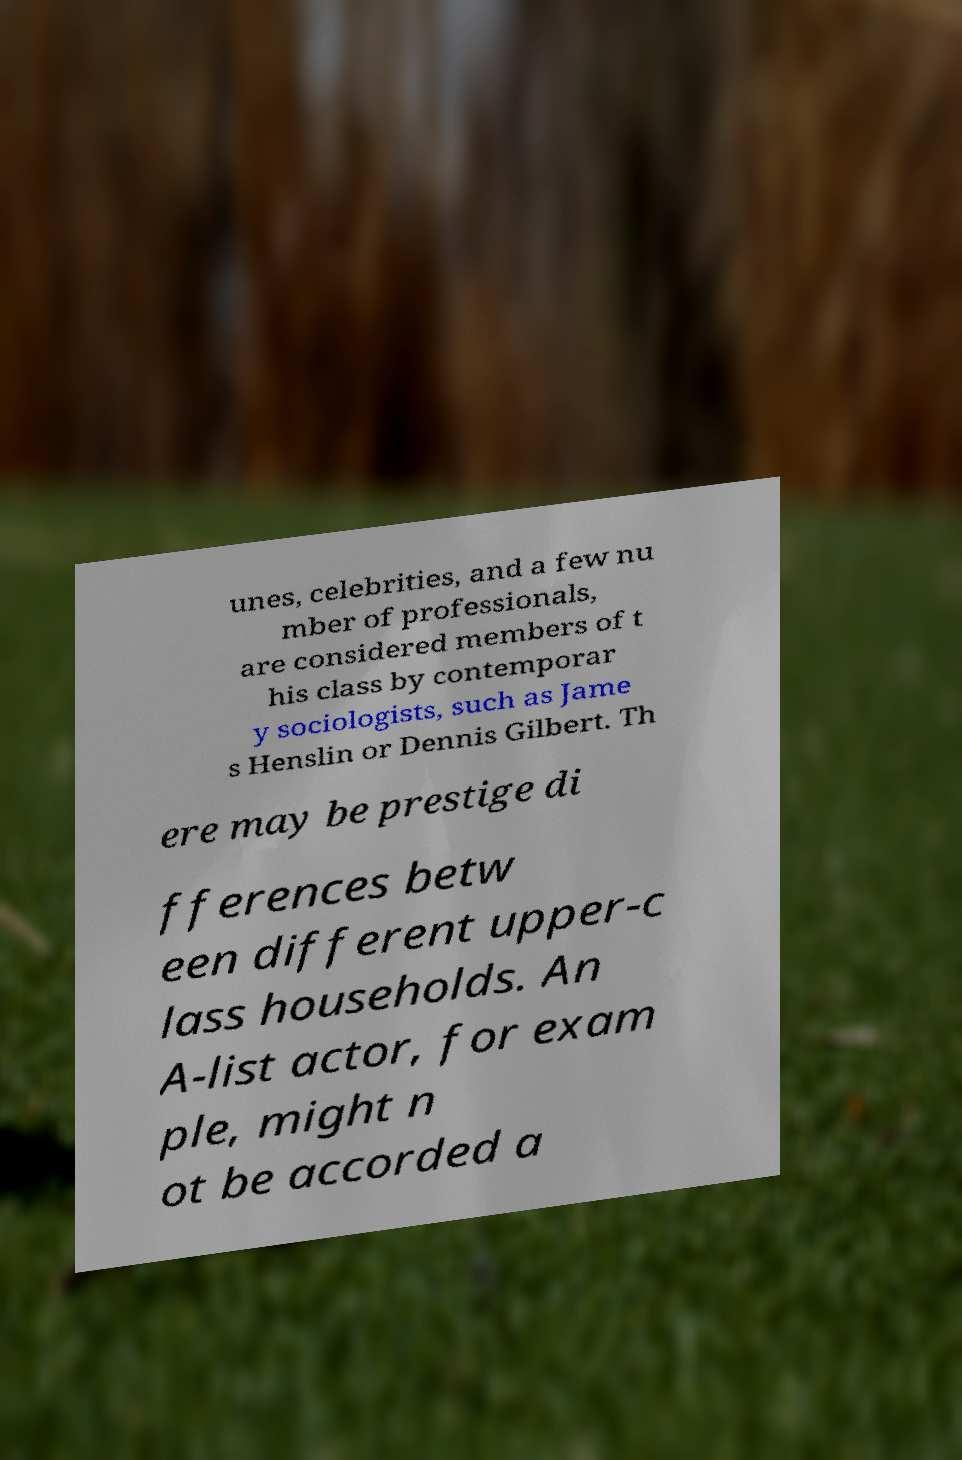Can you accurately transcribe the text from the provided image for me? unes, celebrities, and a few nu mber of professionals, are considered members of t his class by contemporar y sociologists, such as Jame s Henslin or Dennis Gilbert. Th ere may be prestige di fferences betw een different upper-c lass households. An A-list actor, for exam ple, might n ot be accorded a 